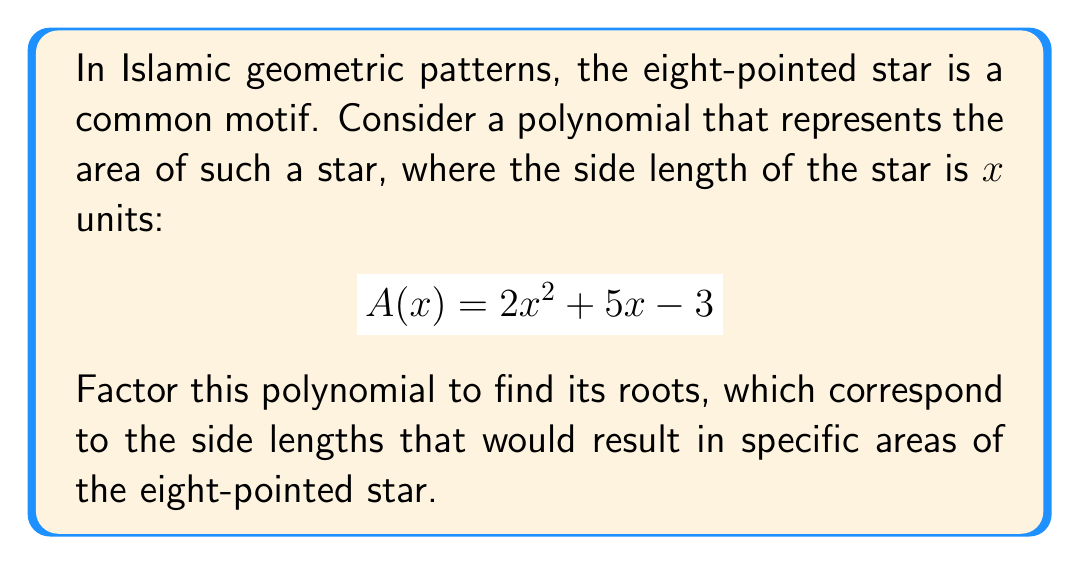Give your solution to this math problem. To factor this quadratic polynomial, we'll use the following steps:

1) First, identify the coefficients:
   $a = 2$, $b = 5$, and $c = -3$

2) Use the quadratic formula: $x = \frac{-b \pm \sqrt{b^2 - 4ac}}{2a}$

3) Substitute the values:
   $$x = \frac{-5 \pm \sqrt{5^2 - 4(2)(-3)}}{2(2)}$$

4) Simplify under the square root:
   $$x = \frac{-5 \pm \sqrt{25 + 24}}{4} = \frac{-5 \pm \sqrt{49}}{4} = \frac{-5 \pm 7}{4}$$

5) This gives us two solutions:
   $$x_1 = \frac{-5 + 7}{4} = \frac{2}{4} = \frac{1}{2}$$
   $$x_2 = \frac{-5 - 7}{4} = \frac{-12}{4} = -3$$

6) Therefore, the factored form of the polynomial is:
   $$A(x) = 2(x - \frac{1}{2})(x + 3)$$

This factorization reveals that the area of the eight-pointed star would be zero when the side length is either $\frac{1}{2}$ or $-3$ units. While a negative length doesn't make physical sense, it's a mathematical solution to the equation.
Answer: $$A(x) = 2(x - \frac{1}{2})(x + 3)$$ 